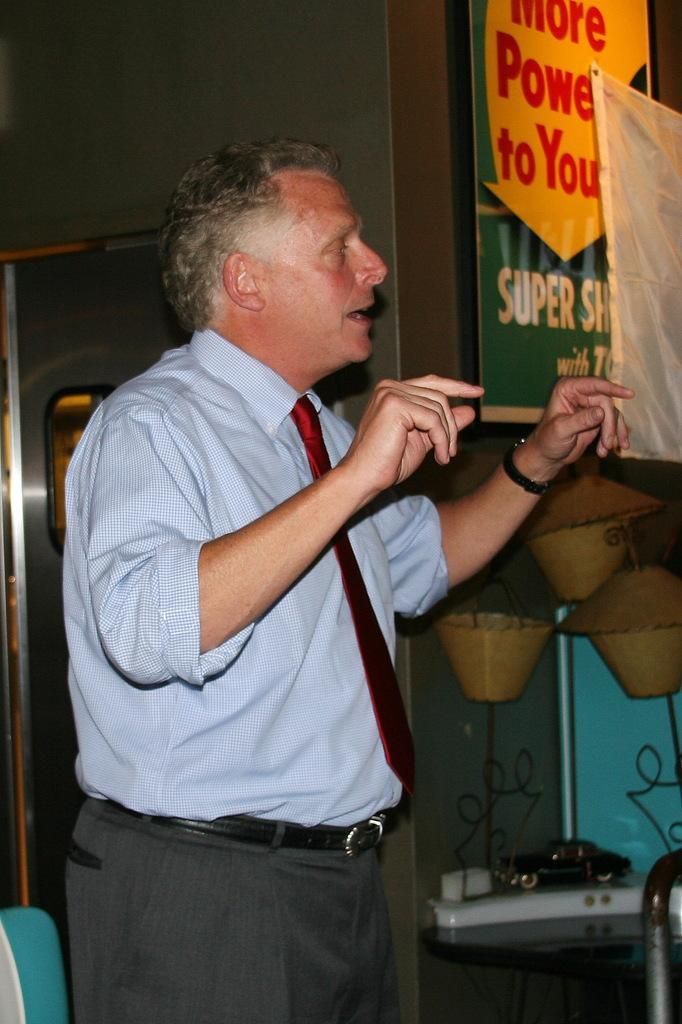<image>
Describe the image concisely. a man with a tie and a sign nearby that says super 